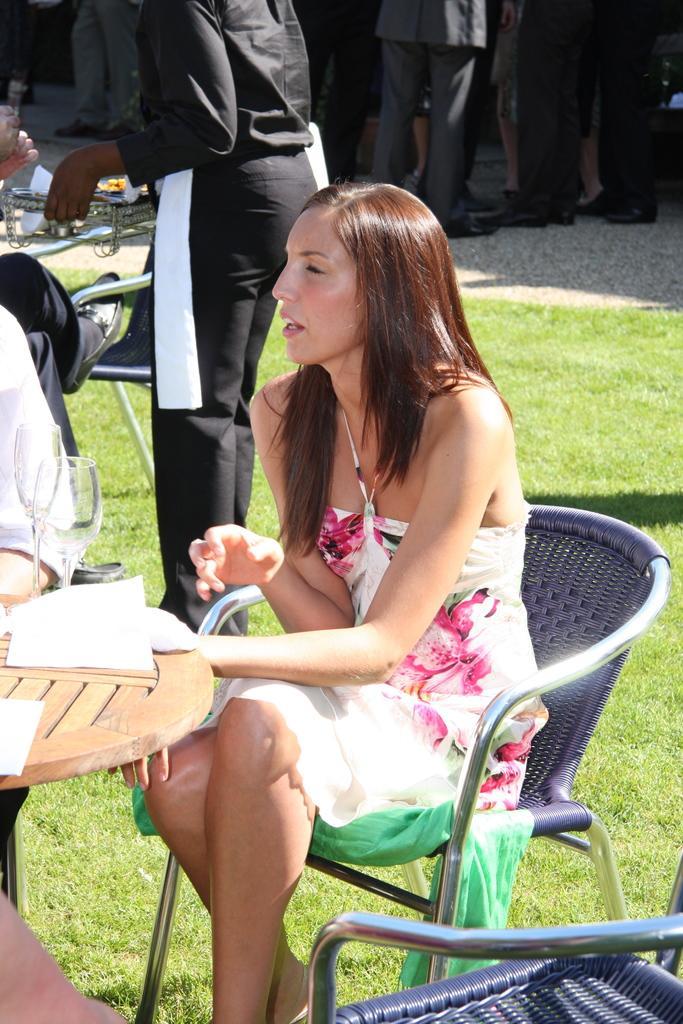Please provide a concise description of this image. There is a woman sitting in a chair in the lawn. There is a table in front of her. On the table there is a paper and glasses. There is a waiter serving behind her on the another table. And there are some people in the background who are doing something there, all are wearing shoes. The woman is having a long hair. 